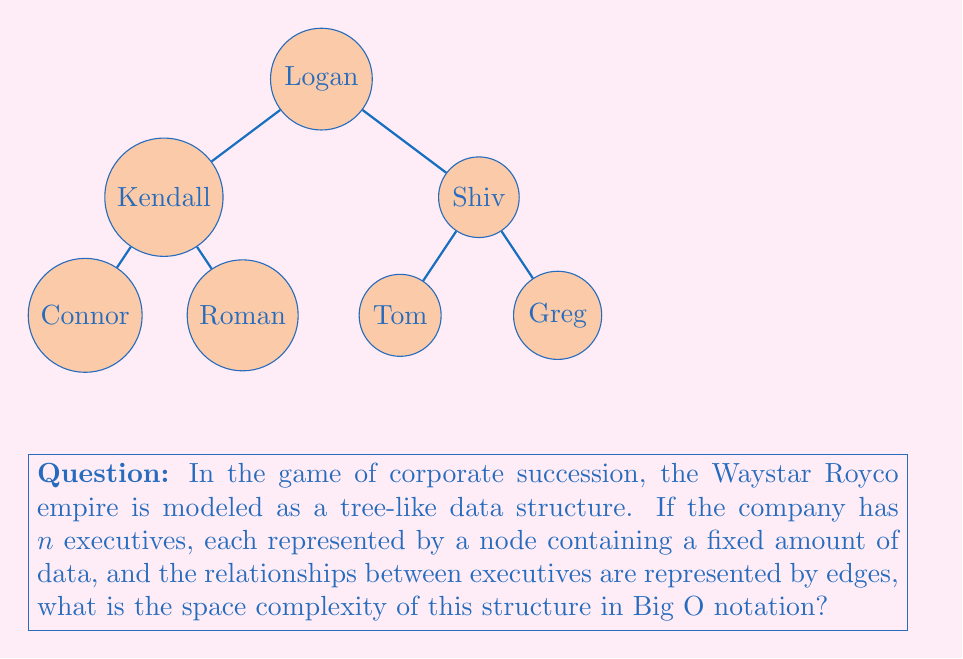Can you answer this question? To evaluate the space complexity of this tree-like structure representing Waystar Royco's corporate hierarchy, we need to consider two main components:

1. Space for nodes:
   - Each executive (node) contains a fixed amount of data.
   - With $n$ executives, the space required for nodes is proportional to $n$.
   - This contributes $O(n)$ to the space complexity.

2. Space for edges:
   - In a tree structure, the number of edges is always one less than the number of nodes.
   - With $n$ nodes, there are $(n-1)$ edges.
   - The space required for edges is also proportional to $n$.
   - This contributes another $O(n)$ to the space complexity.

Combining these two components:
$$\text{Total Space} = O(n) + O(n) = O(n)$$

The space complexity doesn't change when we add the two $O(n)$ terms together, as Big O notation represents the upper bound of growth rate.

In the context of "Succession," this means that as Waystar Royco expands and adds more executives (like when Greg joins the company), the space required to model the corporate structure grows linearly with the number of executives.
Answer: $O(n)$ 